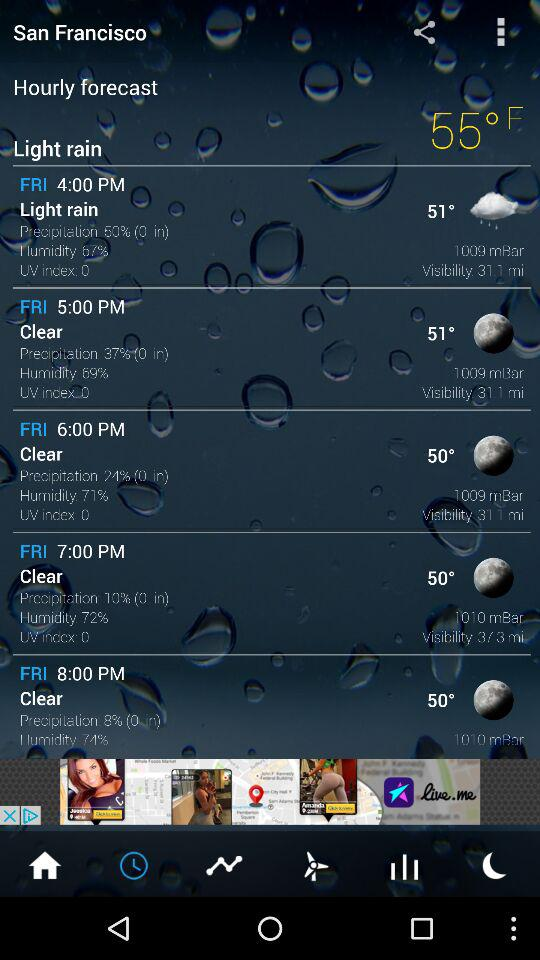What is the current temperature shown on the screen? The current temperature is 55° F. 